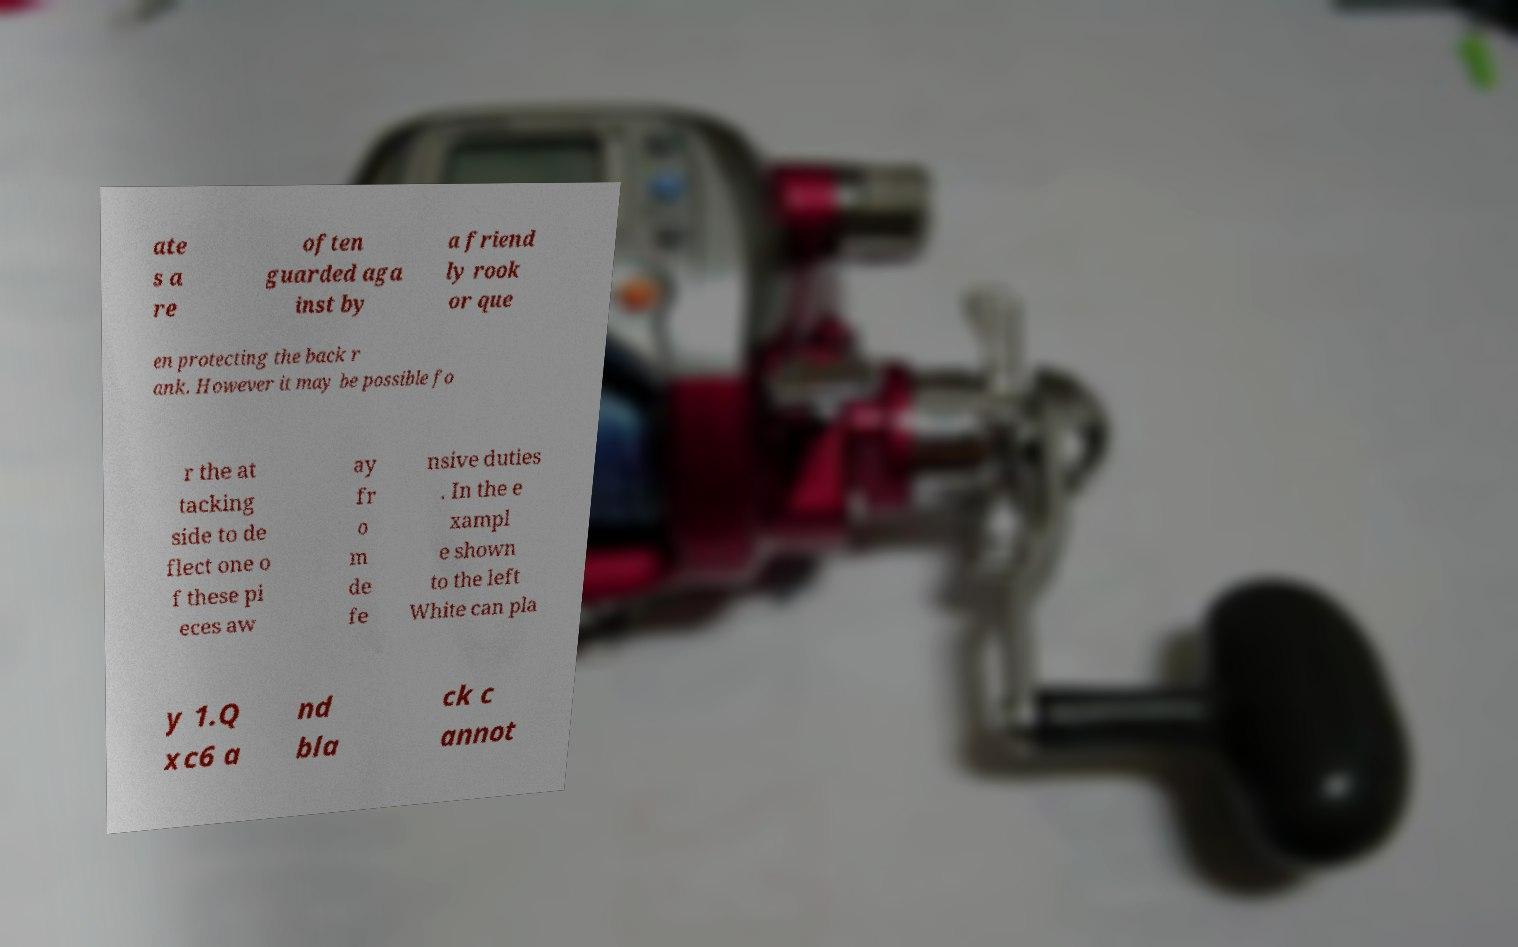Please read and relay the text visible in this image. What does it say? ate s a re often guarded aga inst by a friend ly rook or que en protecting the back r ank. However it may be possible fo r the at tacking side to de flect one o f these pi eces aw ay fr o m de fe nsive duties . In the e xampl e shown to the left White can pla y 1.Q xc6 a nd bla ck c annot 